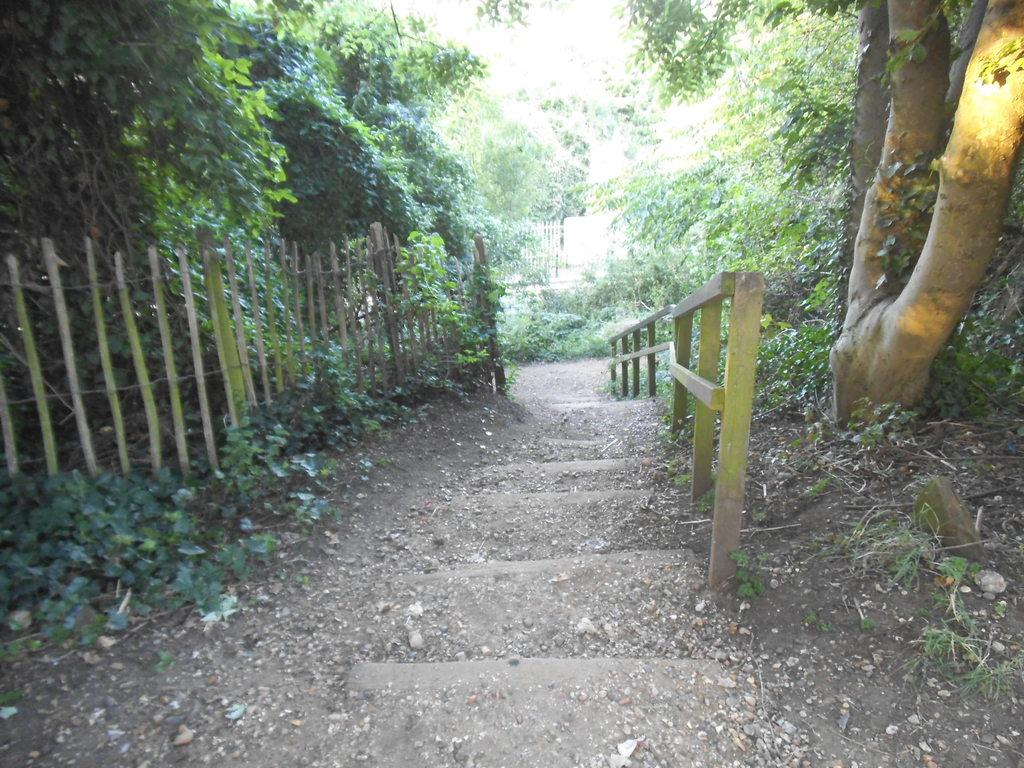What type of setting is depicted in the image? The image is an outside view. What architectural feature can be seen in the image? There are stairs in the image. What type of vegetation is present alongside the stairs? There are plants on both sides of the stairs. What other natural elements can be seen in the image? There are trees in the image. What type of barrier is visible in the image? There is fencing in the image. What type of quilt is draped over the fence in the image? There is no quilt present in the image; it features an outside view with stairs, plants, trees, and fencing. 